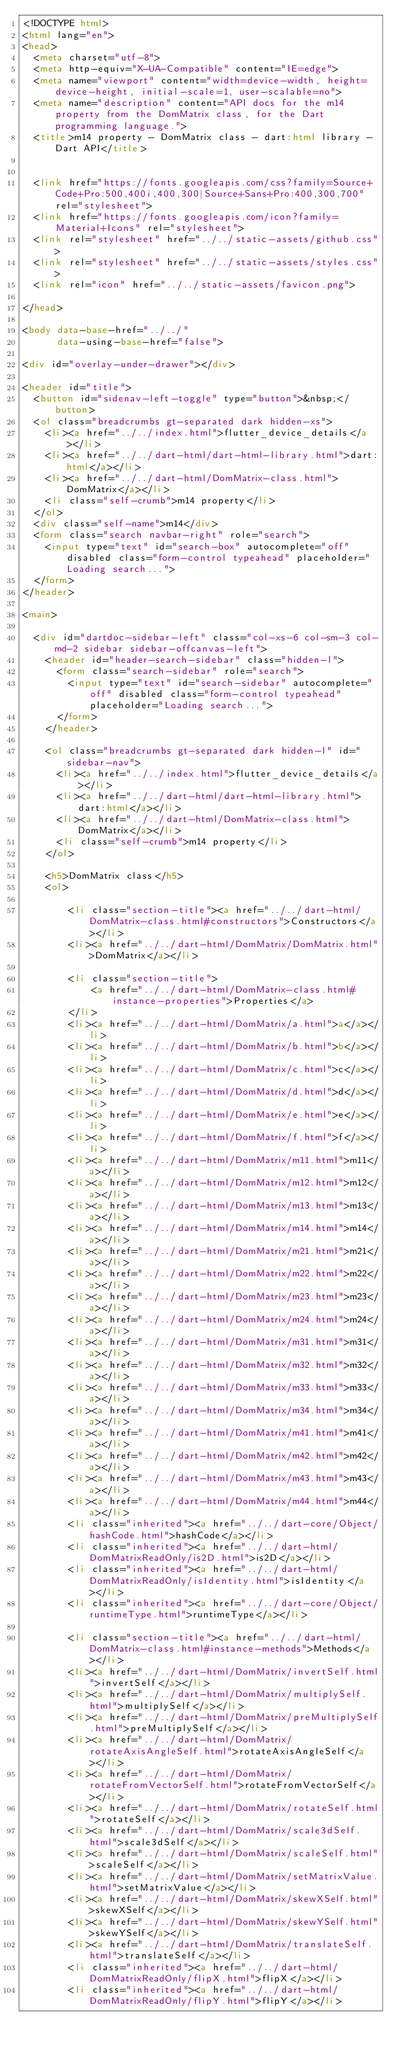Convert code to text. <code><loc_0><loc_0><loc_500><loc_500><_HTML_><!DOCTYPE html>
<html lang="en">
<head>
  <meta charset="utf-8">
  <meta http-equiv="X-UA-Compatible" content="IE=edge">
  <meta name="viewport" content="width=device-width, height=device-height, initial-scale=1, user-scalable=no">
  <meta name="description" content="API docs for the m14 property from the DomMatrix class, for the Dart programming language.">
  <title>m14 property - DomMatrix class - dart:html library - Dart API</title>

  
  <link href="https://fonts.googleapis.com/css?family=Source+Code+Pro:500,400i,400,300|Source+Sans+Pro:400,300,700" rel="stylesheet">
  <link href="https://fonts.googleapis.com/icon?family=Material+Icons" rel="stylesheet">
  <link rel="stylesheet" href="../../static-assets/github.css">
  <link rel="stylesheet" href="../../static-assets/styles.css">
  <link rel="icon" href="../../static-assets/favicon.png">

</head>

<body data-base-href="../../"
      data-using-base-href="false">

<div id="overlay-under-drawer"></div>

<header id="title">
  <button id="sidenav-left-toggle" type="button">&nbsp;</button>
  <ol class="breadcrumbs gt-separated dark hidden-xs">
    <li><a href="../../index.html">flutter_device_details</a></li>
    <li><a href="../../dart-html/dart-html-library.html">dart:html</a></li>
    <li><a href="../../dart-html/DomMatrix-class.html">DomMatrix</a></li>
    <li class="self-crumb">m14 property</li>
  </ol>
  <div class="self-name">m14</div>
  <form class="search navbar-right" role="search">
    <input type="text" id="search-box" autocomplete="off" disabled class="form-control typeahead" placeholder="Loading search...">
  </form>
</header>

<main>

  <div id="dartdoc-sidebar-left" class="col-xs-6 col-sm-3 col-md-2 sidebar sidebar-offcanvas-left">
    <header id="header-search-sidebar" class="hidden-l">
      <form class="search-sidebar" role="search">
        <input type="text" id="search-sidebar" autocomplete="off" disabled class="form-control typeahead" placeholder="Loading search...">
      </form>
    </header>
    
    <ol class="breadcrumbs gt-separated dark hidden-l" id="sidebar-nav">
      <li><a href="../../index.html">flutter_device_details</a></li>
      <li><a href="../../dart-html/dart-html-library.html">dart:html</a></li>
      <li><a href="../../dart-html/DomMatrix-class.html">DomMatrix</a></li>
      <li class="self-crumb">m14 property</li>
    </ol>
    
    <h5>DomMatrix class</h5>
    <ol>
    
        <li class="section-title"><a href="../../dart-html/DomMatrix-class.html#constructors">Constructors</a></li>
        <li><a href="../../dart-html/DomMatrix/DomMatrix.html">DomMatrix</a></li>
    
        <li class="section-title">
            <a href="../../dart-html/DomMatrix-class.html#instance-properties">Properties</a>
        </li>
        <li><a href="../../dart-html/DomMatrix/a.html">a</a></li>
        <li><a href="../../dart-html/DomMatrix/b.html">b</a></li>
        <li><a href="../../dart-html/DomMatrix/c.html">c</a></li>
        <li><a href="../../dart-html/DomMatrix/d.html">d</a></li>
        <li><a href="../../dart-html/DomMatrix/e.html">e</a></li>
        <li><a href="../../dart-html/DomMatrix/f.html">f</a></li>
        <li><a href="../../dart-html/DomMatrix/m11.html">m11</a></li>
        <li><a href="../../dart-html/DomMatrix/m12.html">m12</a></li>
        <li><a href="../../dart-html/DomMatrix/m13.html">m13</a></li>
        <li><a href="../../dart-html/DomMatrix/m14.html">m14</a></li>
        <li><a href="../../dart-html/DomMatrix/m21.html">m21</a></li>
        <li><a href="../../dart-html/DomMatrix/m22.html">m22</a></li>
        <li><a href="../../dart-html/DomMatrix/m23.html">m23</a></li>
        <li><a href="../../dart-html/DomMatrix/m24.html">m24</a></li>
        <li><a href="../../dart-html/DomMatrix/m31.html">m31</a></li>
        <li><a href="../../dart-html/DomMatrix/m32.html">m32</a></li>
        <li><a href="../../dart-html/DomMatrix/m33.html">m33</a></li>
        <li><a href="../../dart-html/DomMatrix/m34.html">m34</a></li>
        <li><a href="../../dart-html/DomMatrix/m41.html">m41</a></li>
        <li><a href="../../dart-html/DomMatrix/m42.html">m42</a></li>
        <li><a href="../../dart-html/DomMatrix/m43.html">m43</a></li>
        <li><a href="../../dart-html/DomMatrix/m44.html">m44</a></li>
        <li class="inherited"><a href="../../dart-core/Object/hashCode.html">hashCode</a></li>
        <li class="inherited"><a href="../../dart-html/DomMatrixReadOnly/is2D.html">is2D</a></li>
        <li class="inherited"><a href="../../dart-html/DomMatrixReadOnly/isIdentity.html">isIdentity</a></li>
        <li class="inherited"><a href="../../dart-core/Object/runtimeType.html">runtimeType</a></li>
    
        <li class="section-title"><a href="../../dart-html/DomMatrix-class.html#instance-methods">Methods</a></li>
        <li><a href="../../dart-html/DomMatrix/invertSelf.html">invertSelf</a></li>
        <li><a href="../../dart-html/DomMatrix/multiplySelf.html">multiplySelf</a></li>
        <li><a href="../../dart-html/DomMatrix/preMultiplySelf.html">preMultiplySelf</a></li>
        <li><a href="../../dart-html/DomMatrix/rotateAxisAngleSelf.html">rotateAxisAngleSelf</a></li>
        <li><a href="../../dart-html/DomMatrix/rotateFromVectorSelf.html">rotateFromVectorSelf</a></li>
        <li><a href="../../dart-html/DomMatrix/rotateSelf.html">rotateSelf</a></li>
        <li><a href="../../dart-html/DomMatrix/scale3dSelf.html">scale3dSelf</a></li>
        <li><a href="../../dart-html/DomMatrix/scaleSelf.html">scaleSelf</a></li>
        <li><a href="../../dart-html/DomMatrix/setMatrixValue.html">setMatrixValue</a></li>
        <li><a href="../../dart-html/DomMatrix/skewXSelf.html">skewXSelf</a></li>
        <li><a href="../../dart-html/DomMatrix/skewYSelf.html">skewYSelf</a></li>
        <li><a href="../../dart-html/DomMatrix/translateSelf.html">translateSelf</a></li>
        <li class="inherited"><a href="../../dart-html/DomMatrixReadOnly/flipX.html">flipX</a></li>
        <li class="inherited"><a href="../../dart-html/DomMatrixReadOnly/flipY.html">flipY</a></li></code> 